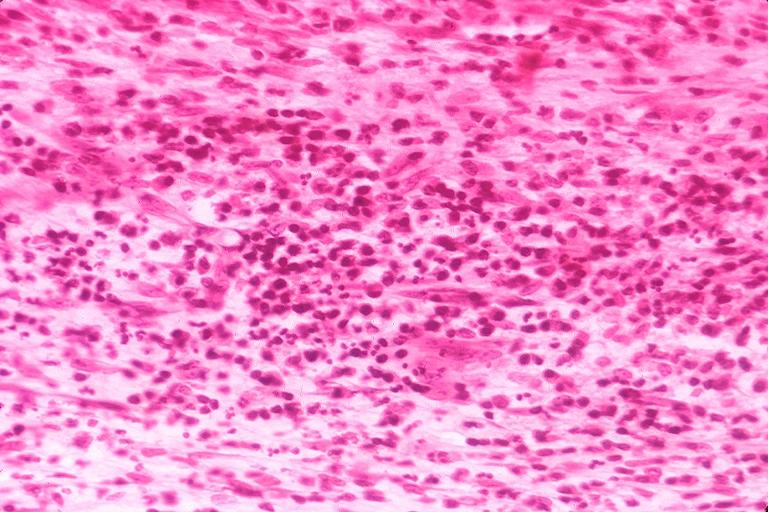where is this?
Answer the question using a single word or phrase. Oral 